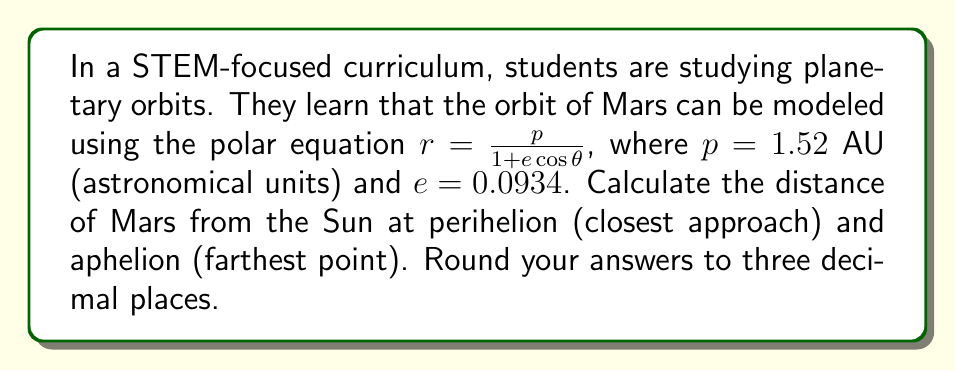Could you help me with this problem? To solve this problem, we need to understand that:

1) The polar equation $r = \frac{p}{1 + e\cos\theta}$ represents an elliptical orbit, where:
   - $r$ is the distance from the focus (Sun) to a point on the ellipse (Mars)
   - $p$ is the semi-latus rectum
   - $e$ is the eccentricity
   - $\theta$ is the angle from the axis of the ellipse

2) At perihelion, Mars is closest to the Sun, which occurs when $\cos\theta = 1$ ($\theta = 0°$).
3) At aphelion, Mars is farthest from the Sun, which occurs when $\cos\theta = -1$ ($\theta = 180°$).

Let's calculate each:

For perihelion:
$$r_{perihelion} = \frac{p}{1 + e\cos(0°)} = \frac{1.52}{1 + 0.0934(1)} = \frac{1.52}{1.0934} \approx 1.390 \text{ AU}$$

For aphelion:
$$r_{aphelion} = \frac{p}{1 + e\cos(180°)} = \frac{1.52}{1 + 0.0934(-1)} = \frac{1.52}{0.9066} \approx 1.677 \text{ AU}$$
Answer: Perihelion distance: 1.390 AU
Aphelion distance: 1.677 AU 